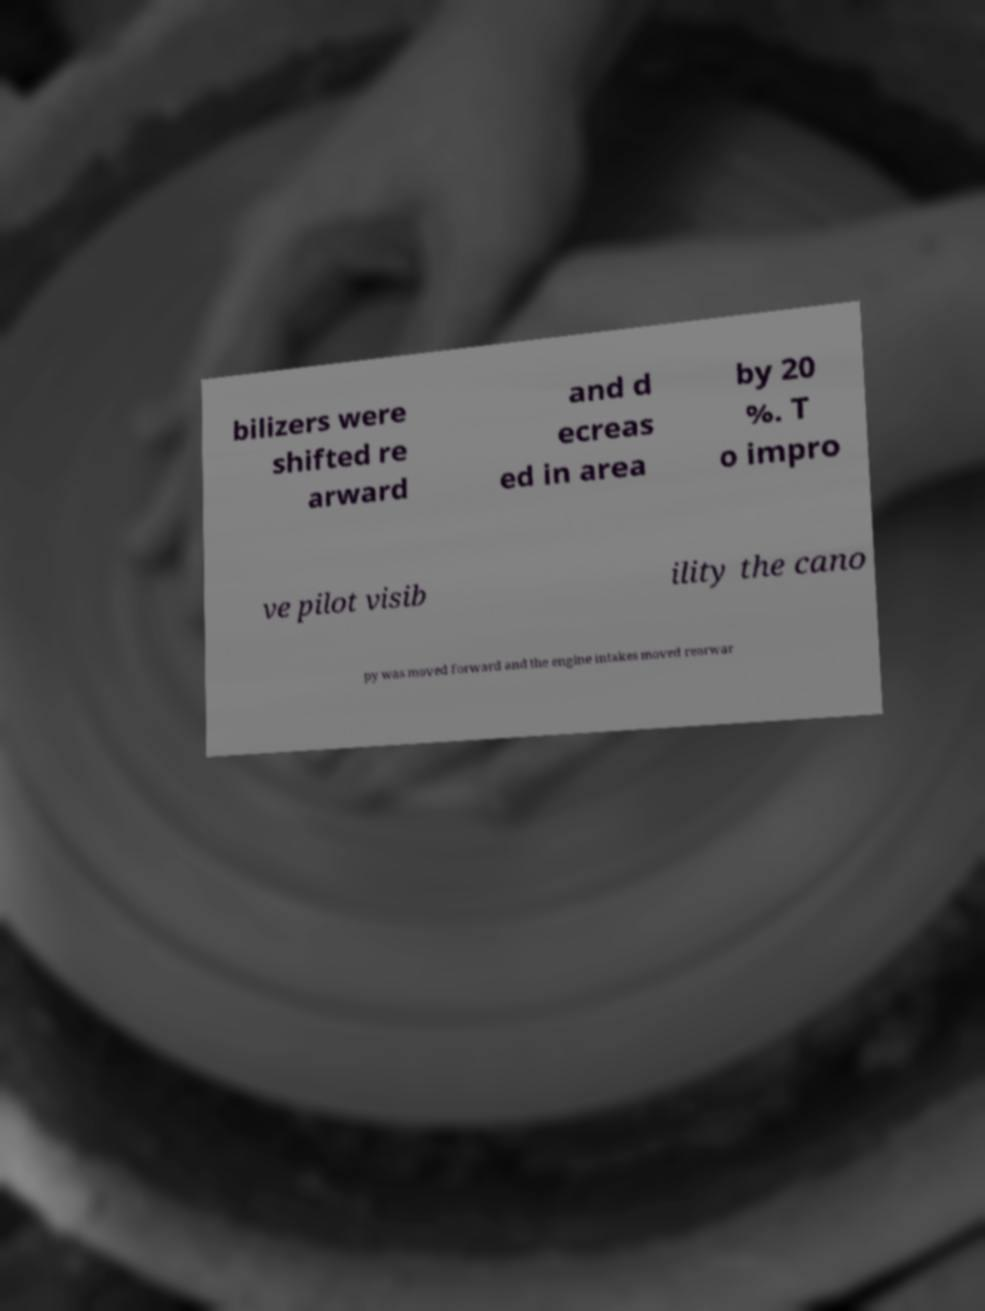What messages or text are displayed in this image? I need them in a readable, typed format. bilizers were shifted re arward and d ecreas ed in area by 20 %. T o impro ve pilot visib ility the cano py was moved forward and the engine intakes moved rearwar 